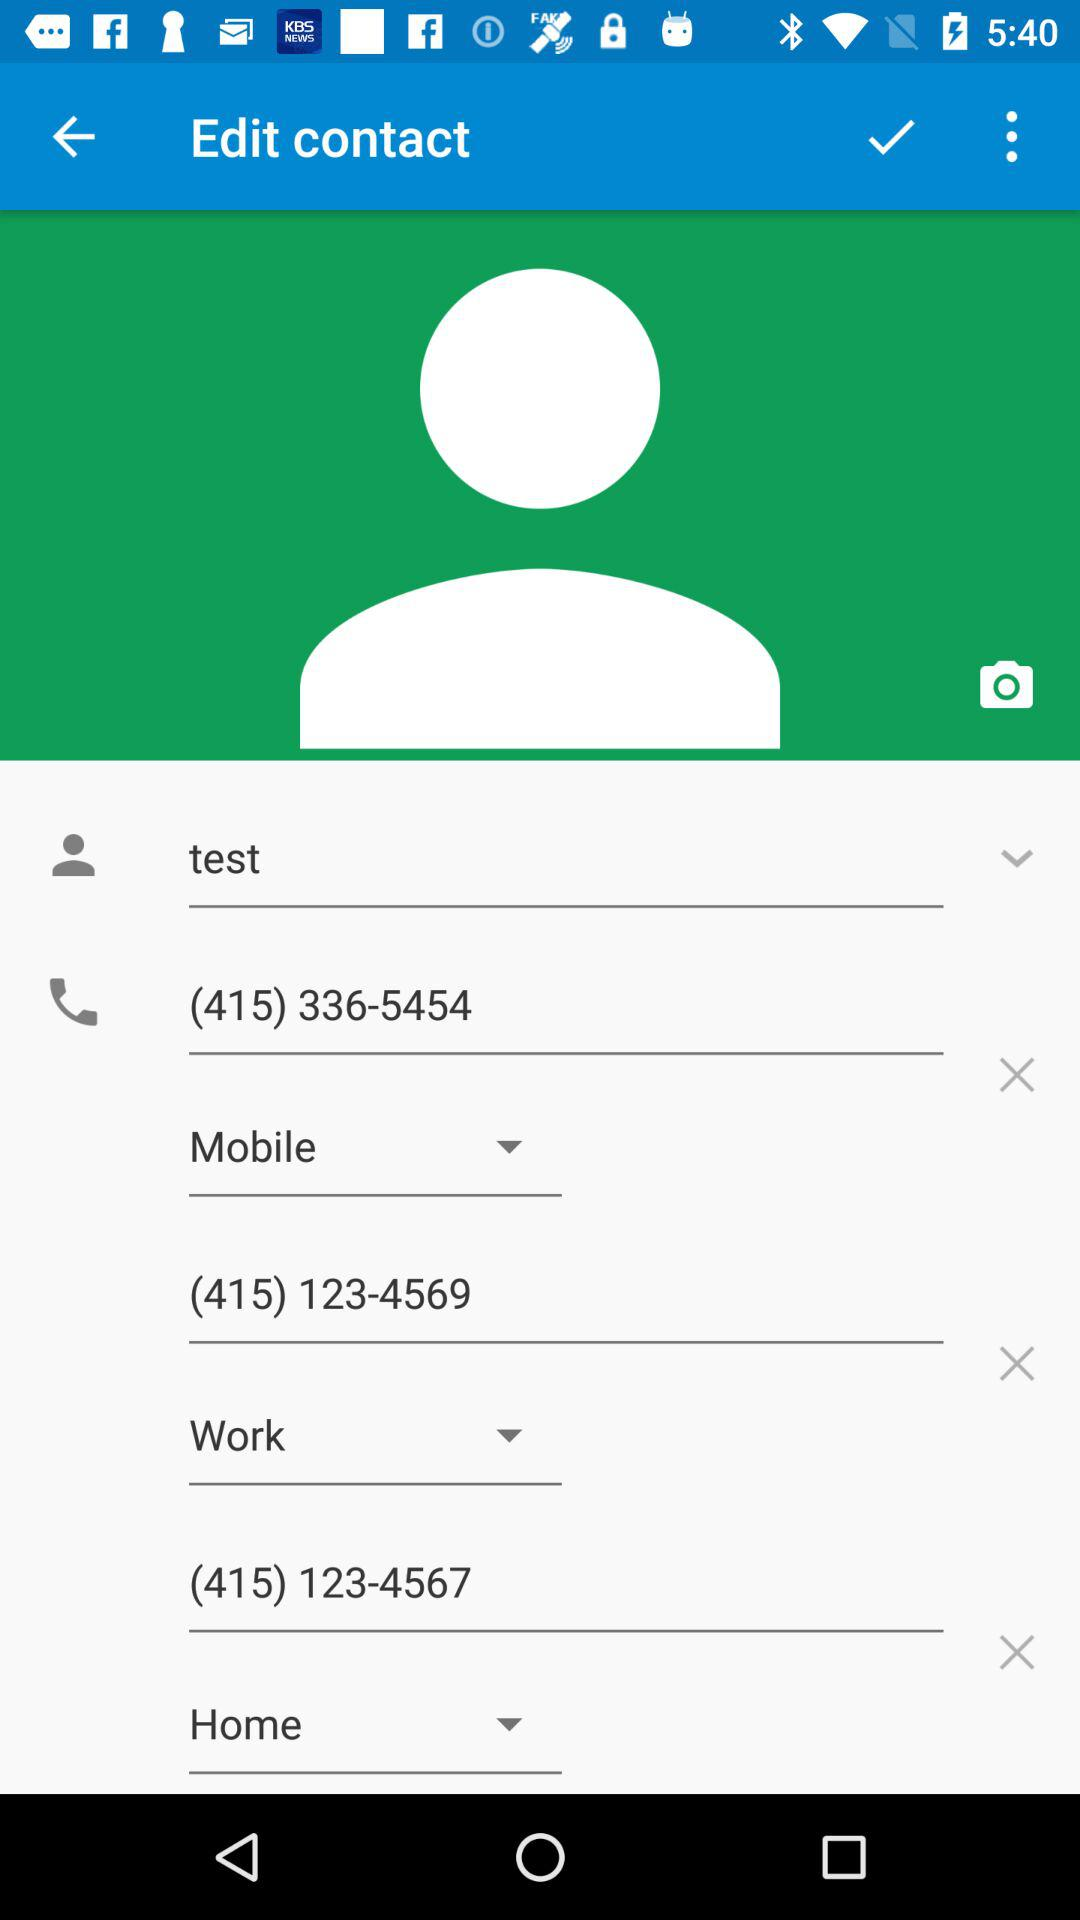What is the username? The username is "test". 